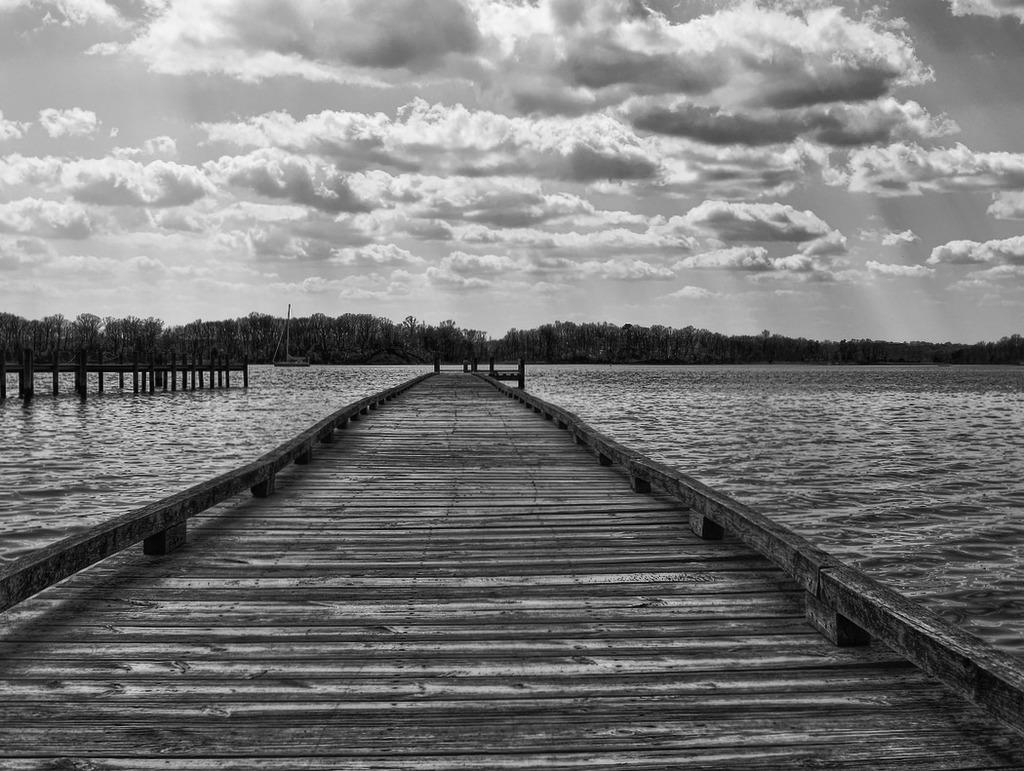What is the main feature of the image? The main feature of the image is a surface of water. What is located near the water in the image? There is a dock in the image. What type of vegetation is present in the image? There are trees in the image. What can be seen in the background of the image? The sky is visible in the background of the image, and it appears to be cloudy. What type of bed is visible in the image? There is no bed present in the image; it features a surface of water, a dock, trees, and a cloudy sky. Is there a battle taking place in the image? There is no battle depicted in the image; it shows a peaceful scene with water, a dock, trees, and a cloudy sky. 